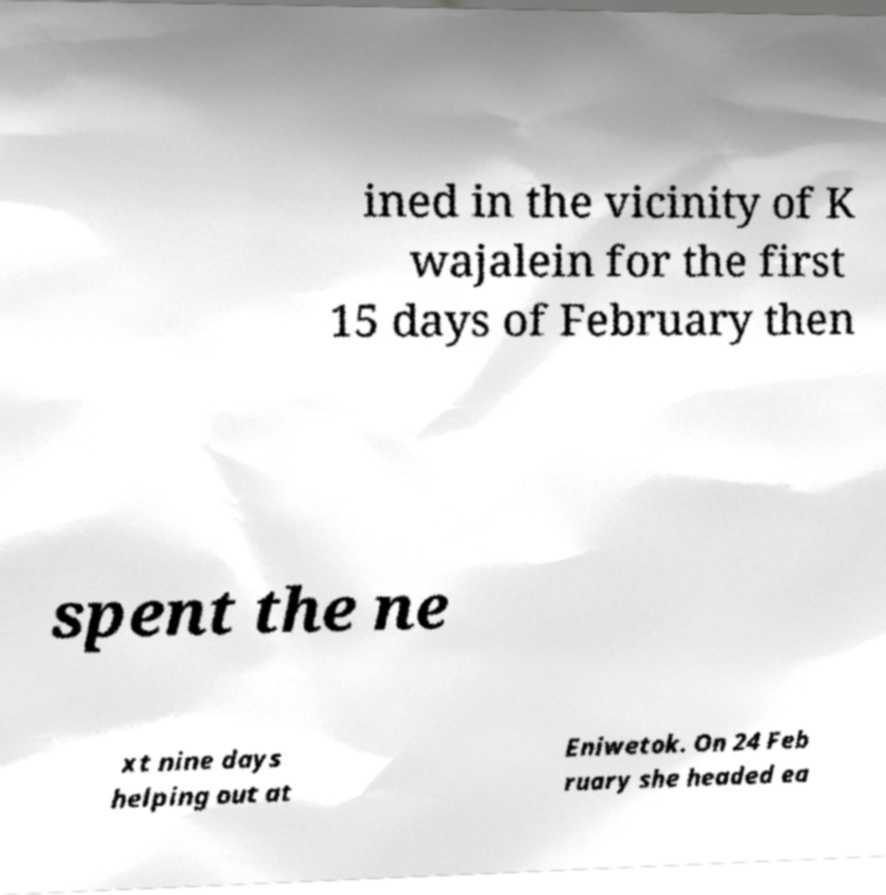There's text embedded in this image that I need extracted. Can you transcribe it verbatim? ined in the vicinity of K wajalein for the first 15 days of February then spent the ne xt nine days helping out at Eniwetok. On 24 Feb ruary she headed ea 